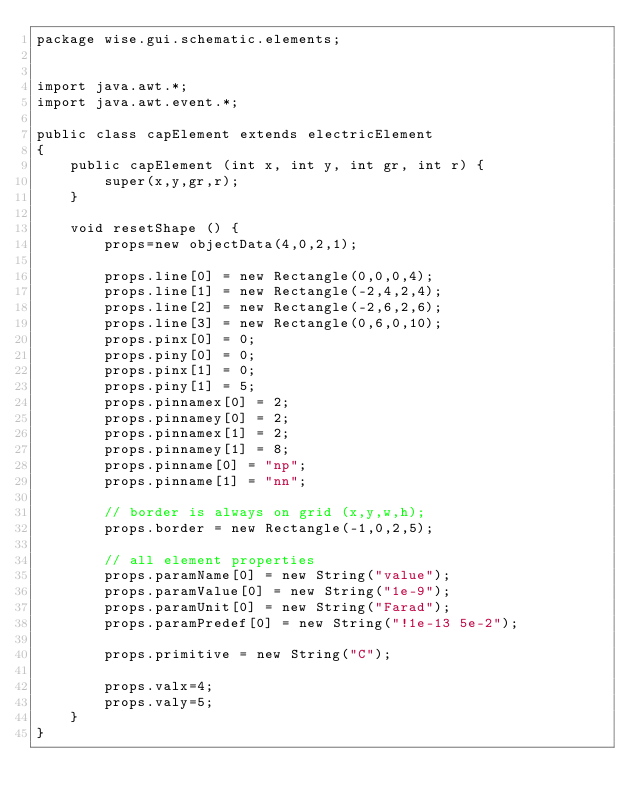Convert code to text. <code><loc_0><loc_0><loc_500><loc_500><_Java_>package wise.gui.schematic.elements;


import java.awt.*;
import java.awt.event.*;

public class capElement extends electricElement
{
    public capElement (int x, int y, int gr, int r) {
        super(x,y,gr,r);
    }

    void resetShape () {
        props=new objectData(4,0,2,1);

        props.line[0] = new Rectangle(0,0,0,4);
        props.line[1] = new Rectangle(-2,4,2,4);
        props.line[2] = new Rectangle(-2,6,2,6);
        props.line[3] = new Rectangle(0,6,0,10);
        props.pinx[0] = 0;
        props.piny[0] = 0;
        props.pinx[1] = 0;
        props.piny[1] = 5;
        props.pinnamex[0] = 2;
        props.pinnamey[0] = 2;
        props.pinnamex[1] = 2;
        props.pinnamey[1] = 8;
        props.pinname[0] = "np";
        props.pinname[1] = "nn";

        // border is always on grid (x,y,w,h);
        props.border = new Rectangle(-1,0,2,5);

        // all element properties
        props.paramName[0] = new String("value");
        props.paramValue[0] = new String("1e-9");
        props.paramUnit[0] = new String("Farad");
        props.paramPredef[0] = new String("!1e-13 5e-2");

        props.primitive = new String("C");

        props.valx=4;
        props.valy=5;
    }
}
</code> 